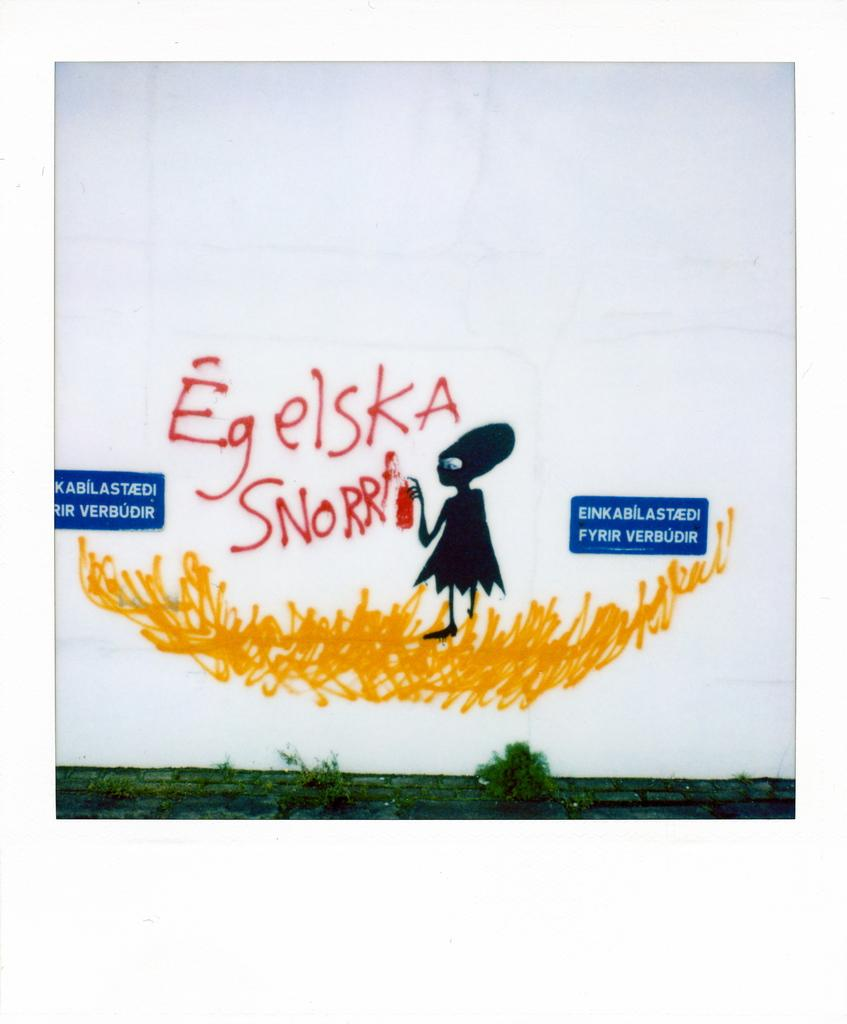What type of artwork is depicted in the image? The image is a painting on the wall. Are there any additional elements attached to the wall? Yes, there are boards attached to the wall. What can be seen in the painting on the wall? Trees are visible in the image. How many fowl are perched on the branches of the trees in the image? There are no fowl visible in the image; only trees are present in the painting. What type of fan is used to create the painting? The image is a painting, not a photograph, so there is no fan involved in its creation. 